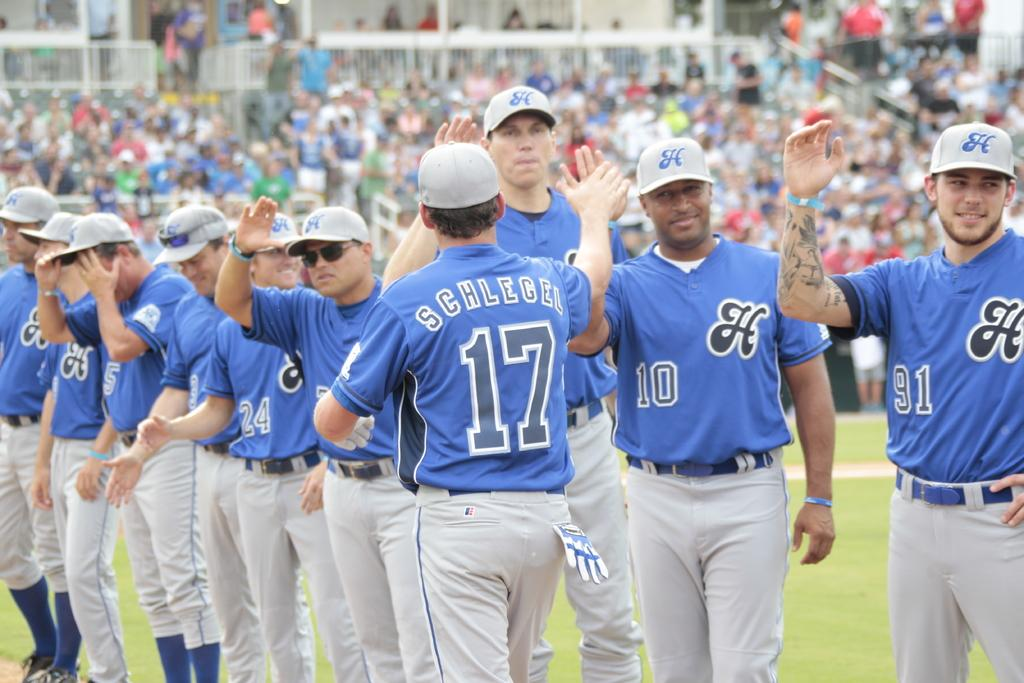Provide a one-sentence caption for the provided image. A team of baseball players in blue and grey, one with Schlegle 17 on their shirt. 